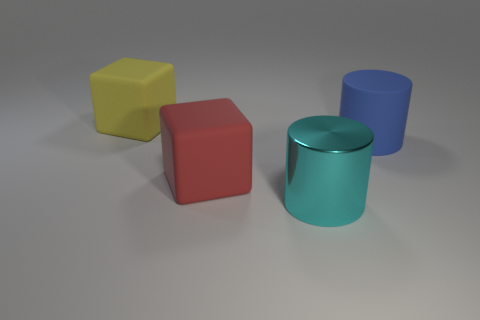Add 1 large blue objects. How many objects exist? 5 Subtract all yellow metallic balls. Subtract all large rubber cubes. How many objects are left? 2 Add 4 big blue cylinders. How many big blue cylinders are left? 5 Add 3 big yellow metallic cylinders. How many big yellow metallic cylinders exist? 3 Subtract 0 cyan cubes. How many objects are left? 4 